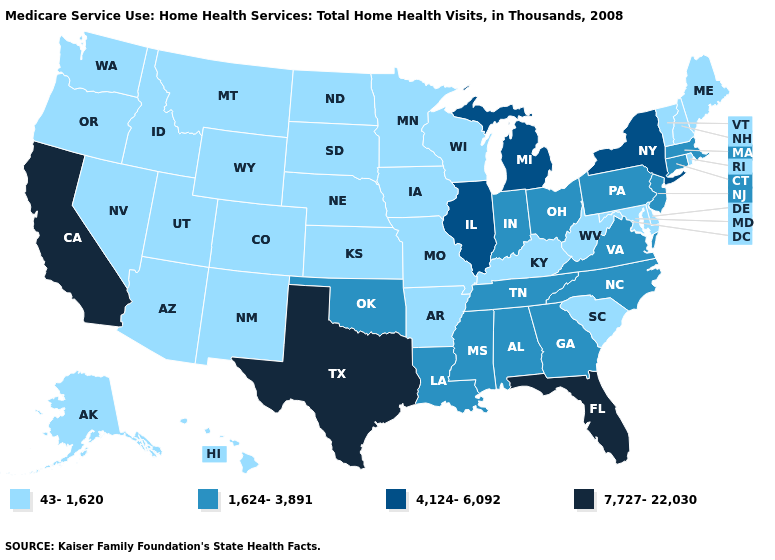What is the highest value in the USA?
Short answer required. 7,727-22,030. Among the states that border Michigan , does Indiana have the lowest value?
Concise answer only. No. Among the states that border Tennessee , which have the lowest value?
Answer briefly. Arkansas, Kentucky, Missouri. Which states have the lowest value in the Northeast?
Be succinct. Maine, New Hampshire, Rhode Island, Vermont. What is the highest value in states that border Delaware?
Short answer required. 1,624-3,891. Name the states that have a value in the range 7,727-22,030?
Concise answer only. California, Florida, Texas. Name the states that have a value in the range 43-1,620?
Keep it brief. Alaska, Arizona, Arkansas, Colorado, Delaware, Hawaii, Idaho, Iowa, Kansas, Kentucky, Maine, Maryland, Minnesota, Missouri, Montana, Nebraska, Nevada, New Hampshire, New Mexico, North Dakota, Oregon, Rhode Island, South Carolina, South Dakota, Utah, Vermont, Washington, West Virginia, Wisconsin, Wyoming. Name the states that have a value in the range 4,124-6,092?
Concise answer only. Illinois, Michigan, New York. Does Texas have the same value as Florida?
Give a very brief answer. Yes. Which states have the lowest value in the USA?
Short answer required. Alaska, Arizona, Arkansas, Colorado, Delaware, Hawaii, Idaho, Iowa, Kansas, Kentucky, Maine, Maryland, Minnesota, Missouri, Montana, Nebraska, Nevada, New Hampshire, New Mexico, North Dakota, Oregon, Rhode Island, South Carolina, South Dakota, Utah, Vermont, Washington, West Virginia, Wisconsin, Wyoming. What is the highest value in states that border Minnesota?
Quick response, please. 43-1,620. What is the highest value in states that border Wyoming?
Be succinct. 43-1,620. Which states hav the highest value in the Northeast?
Answer briefly. New York. Does Virginia have the highest value in the USA?
Give a very brief answer. No. 